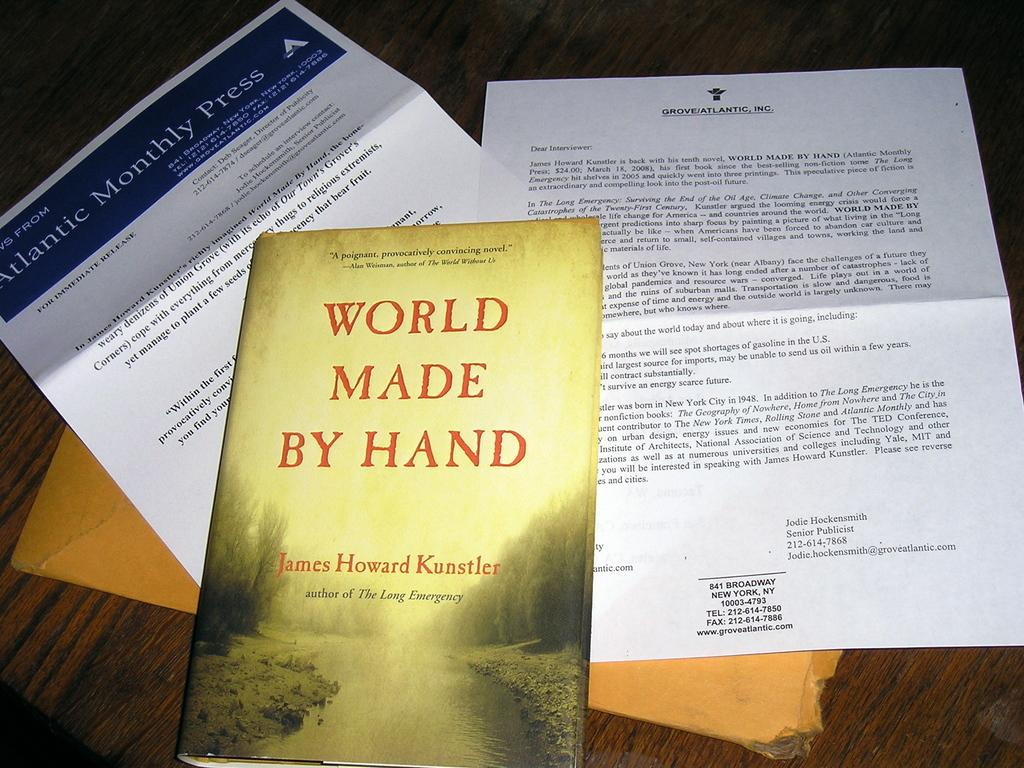<image>
Give a short and clear explanation of the subsequent image. World Made by Hand lays on the table with some papers. 